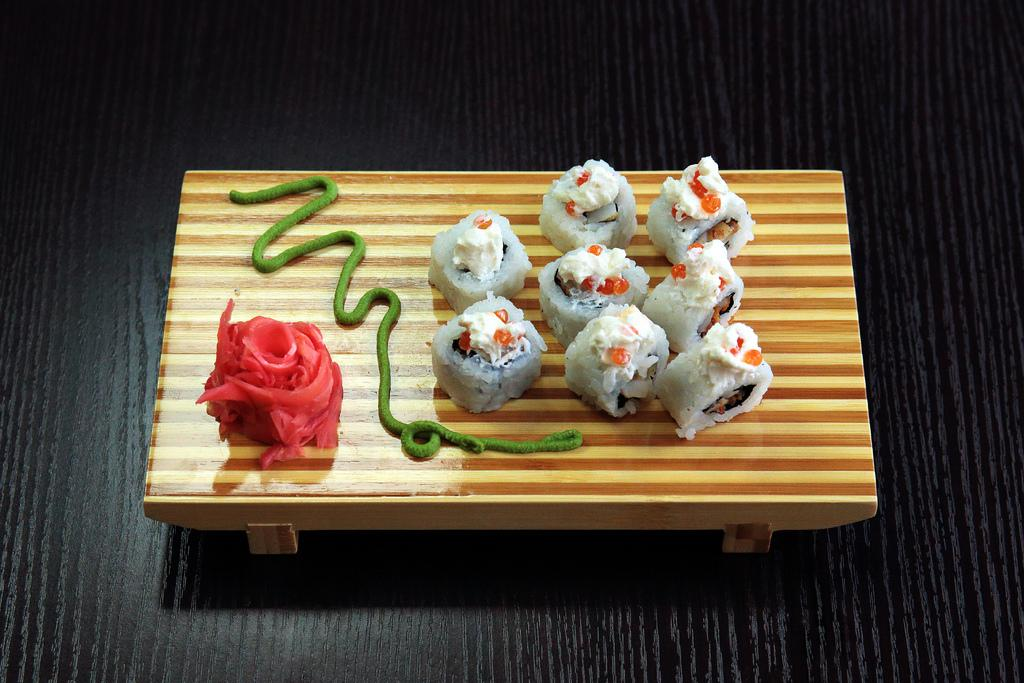What is the color of the surface in the image? The surface in the image is black colored. What is placed on the surface? There is a brown colored table on the surface. What can be seen on the table? There are food items on the table. What colors are the food items? The food items are white, green, and red in color. What type of crime is being committed in the image? There is no crime being committed in the image; it features a black surface with a brown table and food items. Can you see a rat in the image? There is no rat present in the image. 